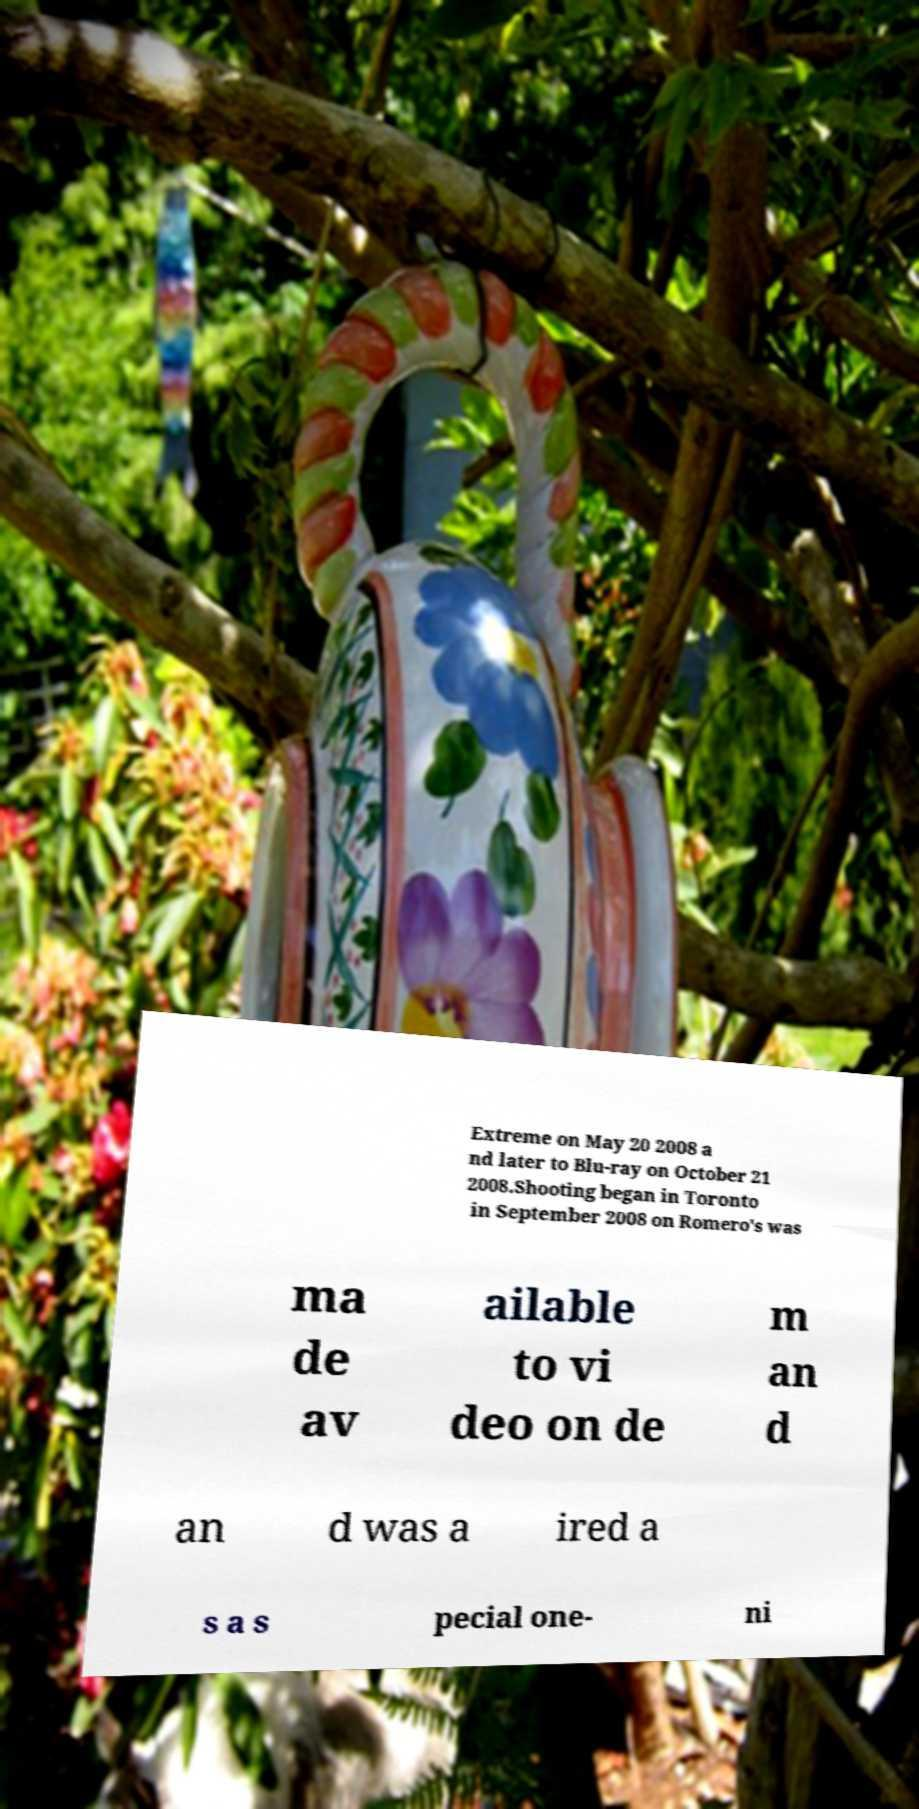I need the written content from this picture converted into text. Can you do that? Extreme on May 20 2008 a nd later to Blu-ray on October 21 2008.Shooting began in Toronto in September 2008 on Romero's was ma de av ailable to vi deo on de m an d an d was a ired a s a s pecial one- ni 